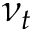Convert formula to latex. <formula><loc_0><loc_0><loc_500><loc_500>\nu _ { t }</formula> 